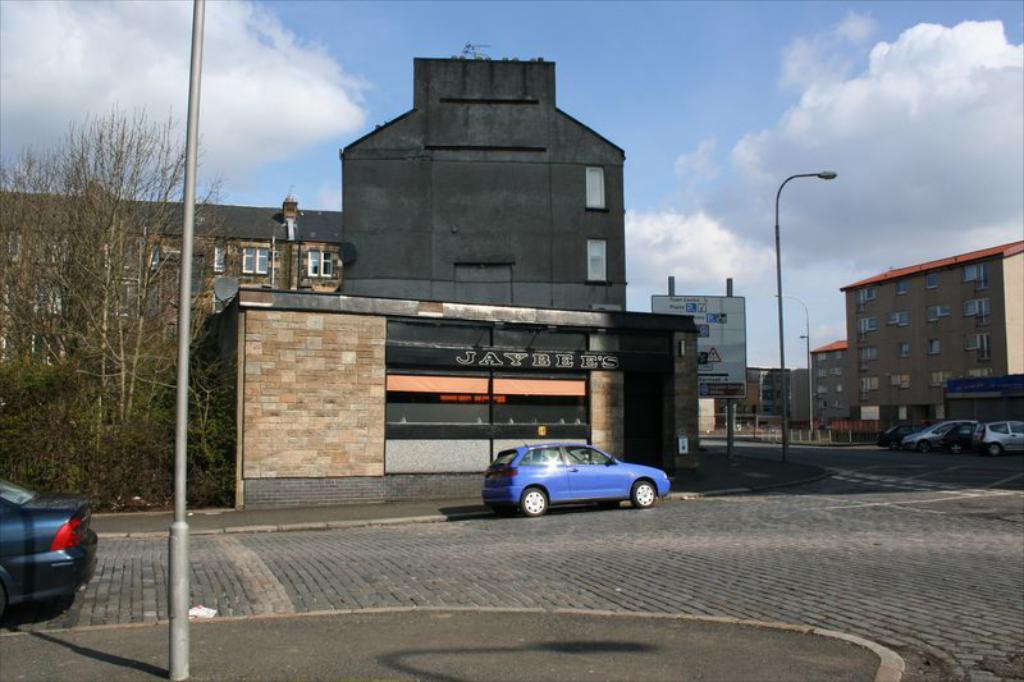What can be seen on the road in the image? There are cars on the road in the image. What structures are present in the image? There are poles, trees, buildings, and a hoarding in the image. What other objects can be seen in the image? There are boards and windows visible in the image. What is visible in the background of the image? The sky is visible in the background of the image, and there are clouds in the sky. How many sticks are being used to build the houses in the image? There are no houses present in the image, so there are no sticks being used for construction. What channel is being broadcasted on the hoarding in the image? There is no information about a channel being broadcasted on the hoarding in the image. 